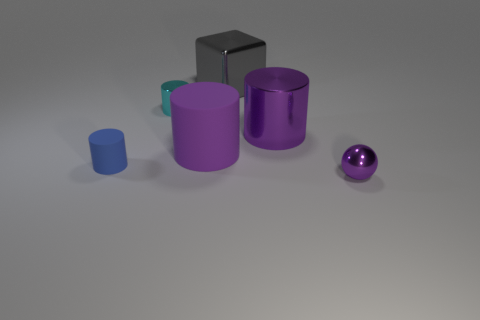Subtract all small cyan cylinders. How many cylinders are left? 3 Add 3 shiny cylinders. How many objects exist? 9 Subtract all purple cylinders. How many cylinders are left? 2 Subtract 1 blocks. How many blocks are left? 0 Add 1 rubber cylinders. How many rubber cylinders exist? 3 Subtract 1 blue cylinders. How many objects are left? 5 Subtract all cubes. How many objects are left? 5 Subtract all yellow cylinders. Subtract all cyan cubes. How many cylinders are left? 4 Subtract all yellow spheres. How many yellow cubes are left? 0 Subtract all large blue metal cubes. Subtract all metal blocks. How many objects are left? 5 